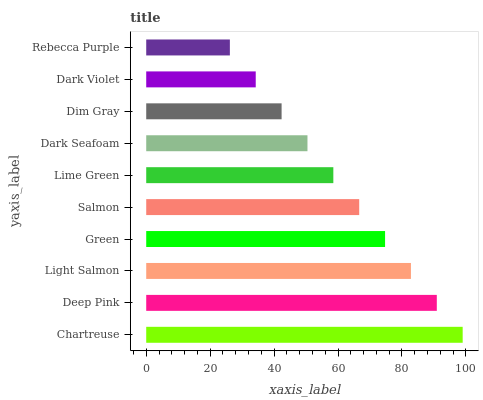Is Rebecca Purple the minimum?
Answer yes or no. Yes. Is Chartreuse the maximum?
Answer yes or no. Yes. Is Deep Pink the minimum?
Answer yes or no. No. Is Deep Pink the maximum?
Answer yes or no. No. Is Chartreuse greater than Deep Pink?
Answer yes or no. Yes. Is Deep Pink less than Chartreuse?
Answer yes or no. Yes. Is Deep Pink greater than Chartreuse?
Answer yes or no. No. Is Chartreuse less than Deep Pink?
Answer yes or no. No. Is Salmon the high median?
Answer yes or no. Yes. Is Lime Green the low median?
Answer yes or no. Yes. Is Dark Violet the high median?
Answer yes or no. No. Is Dim Gray the low median?
Answer yes or no. No. 